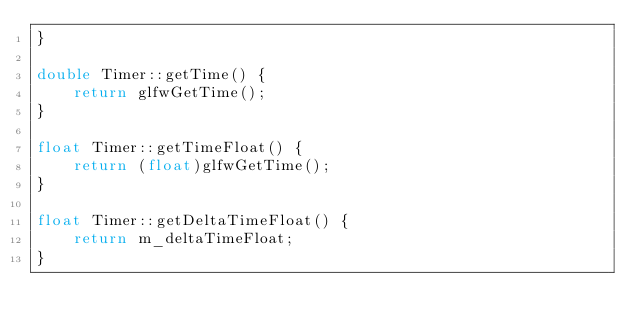Convert code to text. <code><loc_0><loc_0><loc_500><loc_500><_C++_>}

double Timer::getTime() {
    return glfwGetTime();
}

float Timer::getTimeFloat() {
    return (float)glfwGetTime();
}

float Timer::getDeltaTimeFloat() {
    return m_deltaTimeFloat;
}</code> 